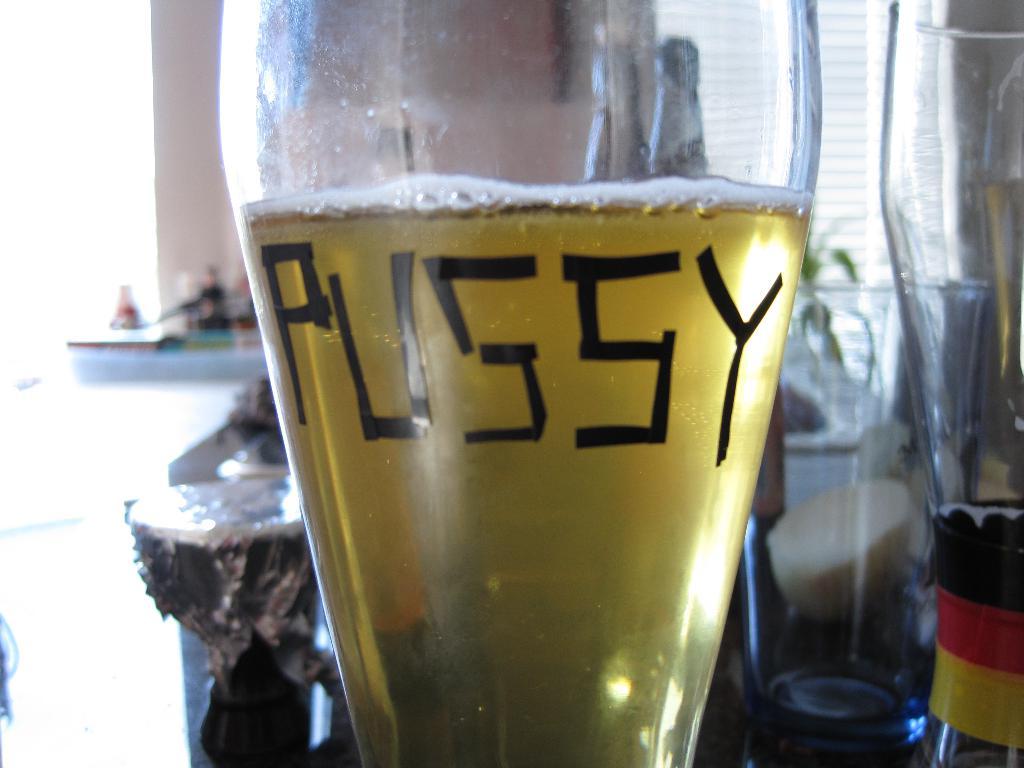What does the glass crudely say?
Your answer should be very brief. Pussy. 